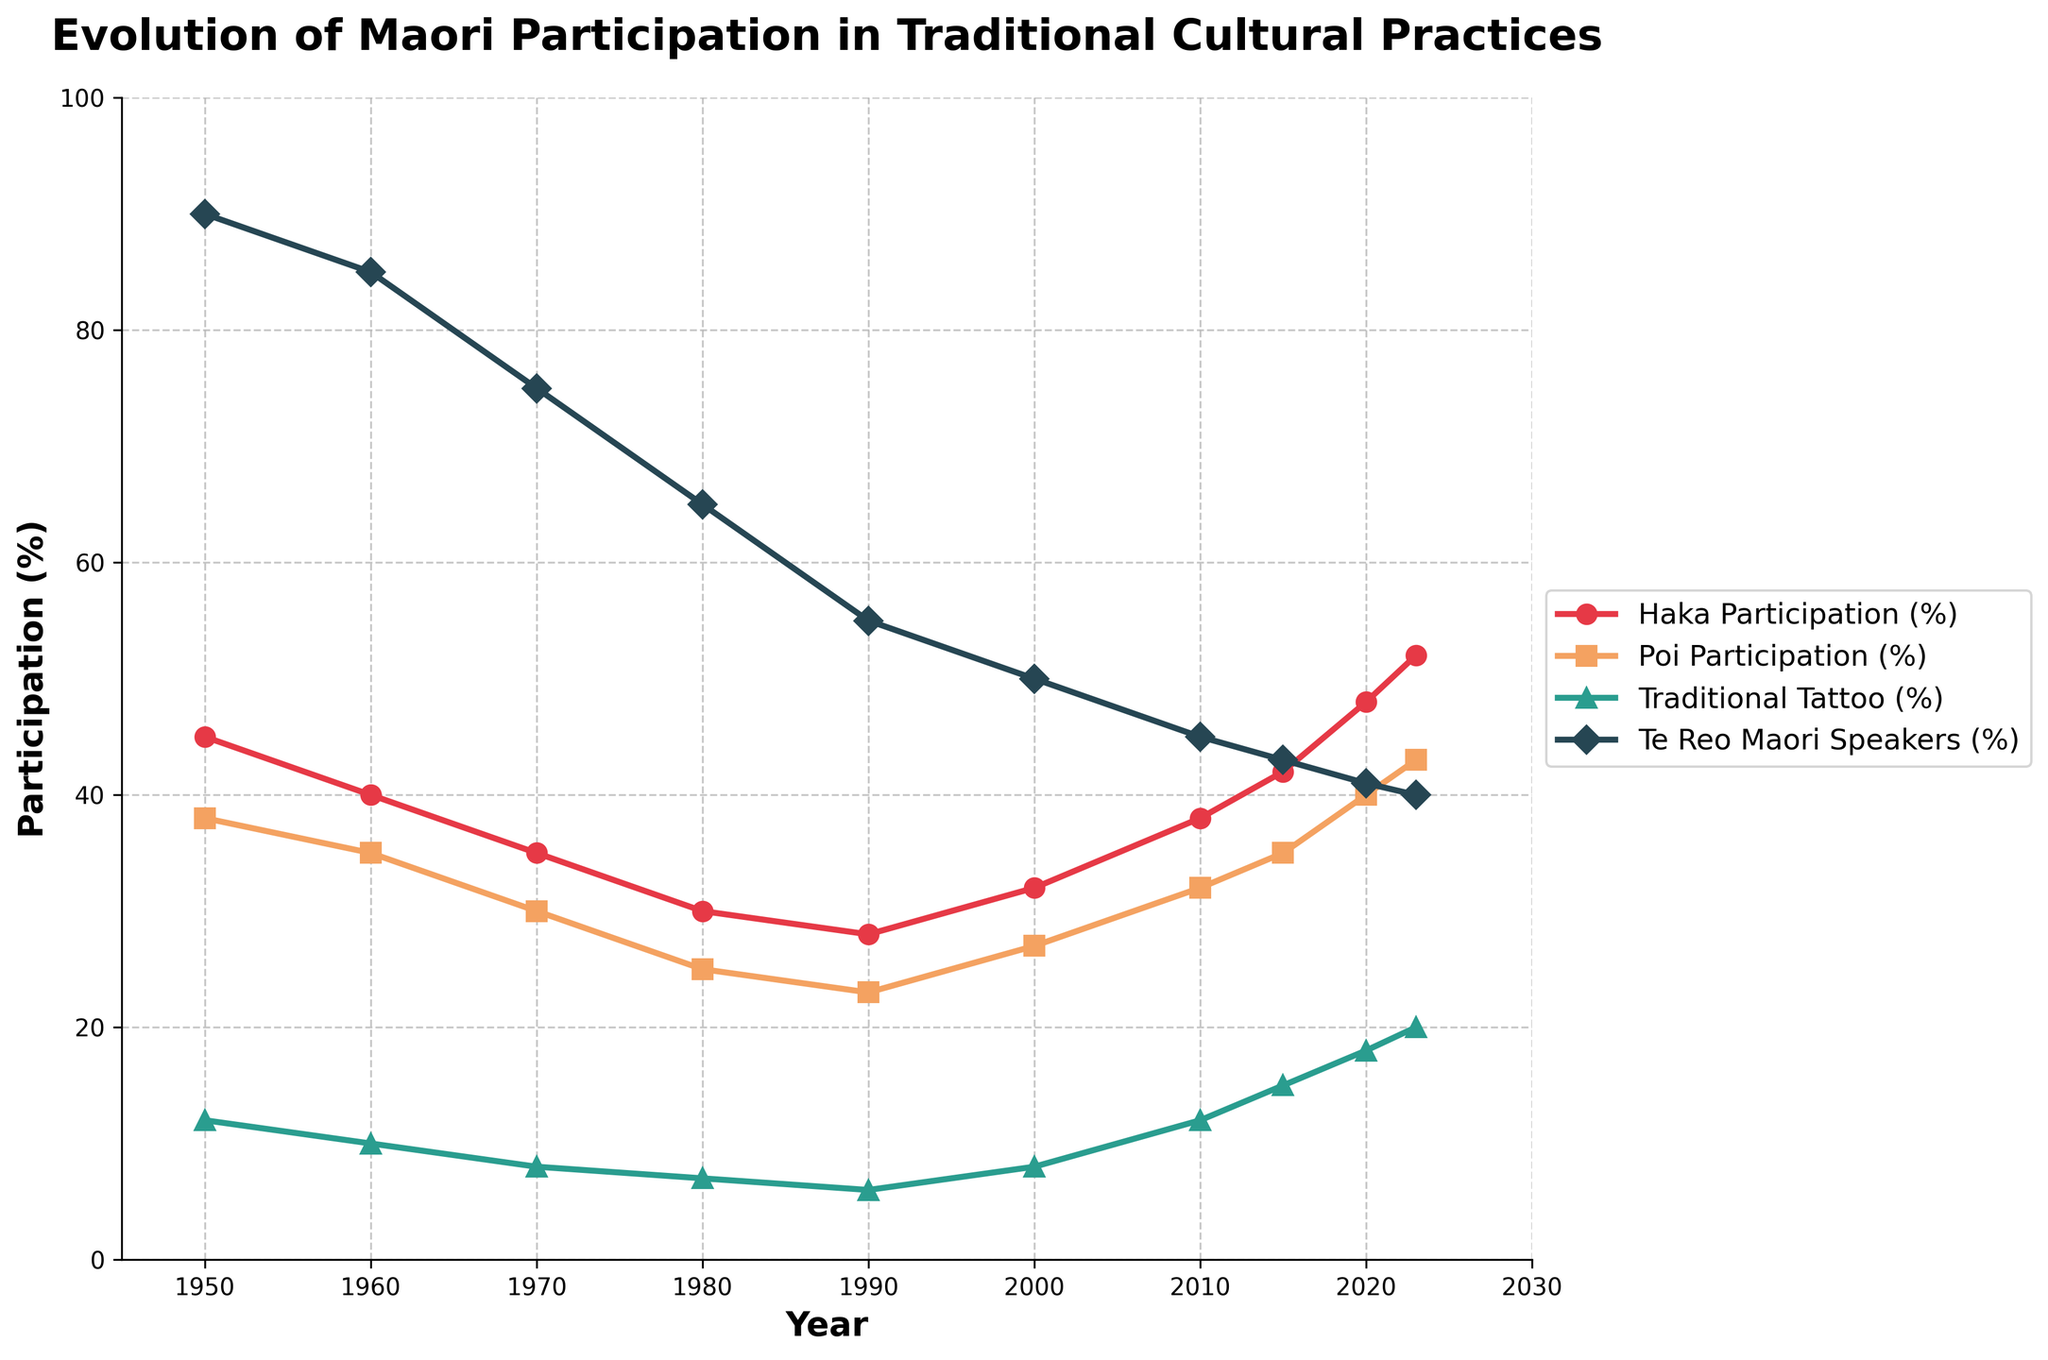What trend do you observe in Haka participation over the years? To determine the trend in Haka participation, observe how the data points for Haka change over time from 1950 to 2023. The line representing Haka participation (%), identified by its unique color and markers, shows an initial decline until 1990, but then it begins to rise steadily from 2000 to 2023.
Answer: Haka participation decreased, then increased Which year had the lowest participation in Te Reo Maori speaking? Locate the line representing Te Reo Maori speakers (%) and identify the year corresponding to the lowest data point on that line. From the figure, the lowest point is observed in 2023 with a participation of 40%.
Answer: 2023 Compare the participation in Poi and traditional tattoo in 2000. Which was higher, and by how much? Locate the data points for Poi Participation (%) and Traditional Tattoo (%) in the year 2000. Poi participation is 27%, and Traditional Tattoo is 8%. Subtract 8% from 27% to find the difference.
Answer: Poi participation was higher by 19% What is the average participation rate in Haka from 1950 to 2023? Sum the Haka participation percentages for each year and divide by the number of data points (10 years). (45+40+35+30+28+32+38+42+48+52)/10 = 39
Answer: 39% How did the participation in Traditional Tattoo change from 1990 to 2023? Look at the data points for Traditional Tattoo (%) in 1990 and 2023. Traditional Tattoo participation was 6% in 1990 and increased to 20% in 2023. Calculating the change: 20% - 6% = 14%.
Answer: Increased by 14% Which cultural practice has the highest participation in 2010, and what is the value? Identify the participation rates of each cultural practice in 2010. Compare the values of Haka (38%), Poi (32%), Traditional Tattoo (12%), and Te Reo Maori Speakers (45%). The highest value is Te Reo Maori Speakers at 45%.
Answer: Te Reo Maori Speakers at 45% What is the general trend of Poi participation from 1980 to 2023? Examine the data points for Poi Participation (%) from 1980 to 2023. Initially, Poi participation was 25% in 1980, decreasing until 1990 (23%) and then showing a steady increase to 43% in 2023.
Answer: Decreased then increased In which year did Haka participation see a sharp increase compared to the previous year? Compare the Haka participation percentages for consecutive years and find the largest increase. The sharpest increase is observed between 2015 (42%) and 2020 (48%), a difference of 6%.
Answer: 2020 